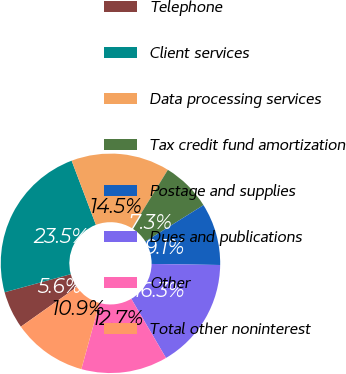Convert chart. <chart><loc_0><loc_0><loc_500><loc_500><pie_chart><fcel>Telephone<fcel>Client services<fcel>Data processing services<fcel>Tax credit fund amortization<fcel>Postage and supplies<fcel>Dues and publications<fcel>Other<fcel>Total other noninterest<nl><fcel>5.55%<fcel>23.49%<fcel>14.52%<fcel>7.34%<fcel>9.14%<fcel>16.31%<fcel>12.72%<fcel>10.93%<nl></chart> 